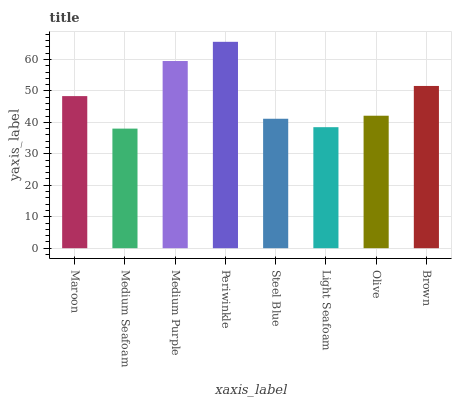Is Medium Seafoam the minimum?
Answer yes or no. Yes. Is Periwinkle the maximum?
Answer yes or no. Yes. Is Medium Purple the minimum?
Answer yes or no. No. Is Medium Purple the maximum?
Answer yes or no. No. Is Medium Purple greater than Medium Seafoam?
Answer yes or no. Yes. Is Medium Seafoam less than Medium Purple?
Answer yes or no. Yes. Is Medium Seafoam greater than Medium Purple?
Answer yes or no. No. Is Medium Purple less than Medium Seafoam?
Answer yes or no. No. Is Maroon the high median?
Answer yes or no. Yes. Is Olive the low median?
Answer yes or no. Yes. Is Olive the high median?
Answer yes or no. No. Is Light Seafoam the low median?
Answer yes or no. No. 